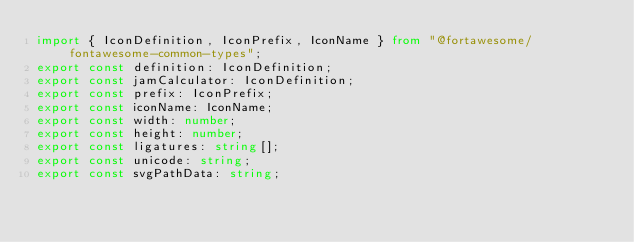<code> <loc_0><loc_0><loc_500><loc_500><_TypeScript_>import { IconDefinition, IconPrefix, IconName } from "@fortawesome/fontawesome-common-types";
export const definition: IconDefinition;
export const jamCalculator: IconDefinition;
export const prefix: IconPrefix;
export const iconName: IconName;
export const width: number;
export const height: number;
export const ligatures: string[];
export const unicode: string;
export const svgPathData: string;</code> 